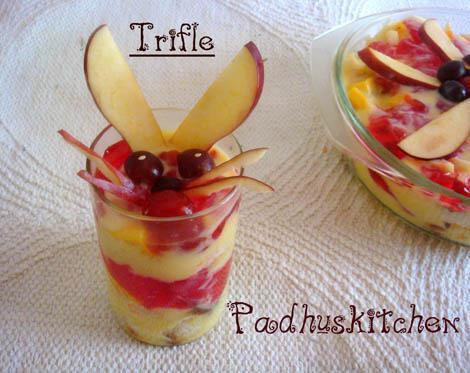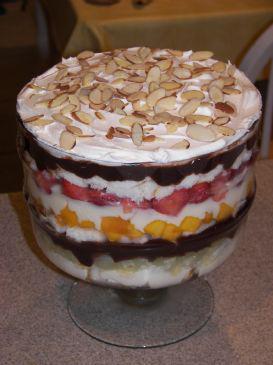The first image is the image on the left, the second image is the image on the right. For the images displayed, is the sentence "A trifle is garnished with red fruit on white whipped cream." factually correct? Answer yes or no. No. 